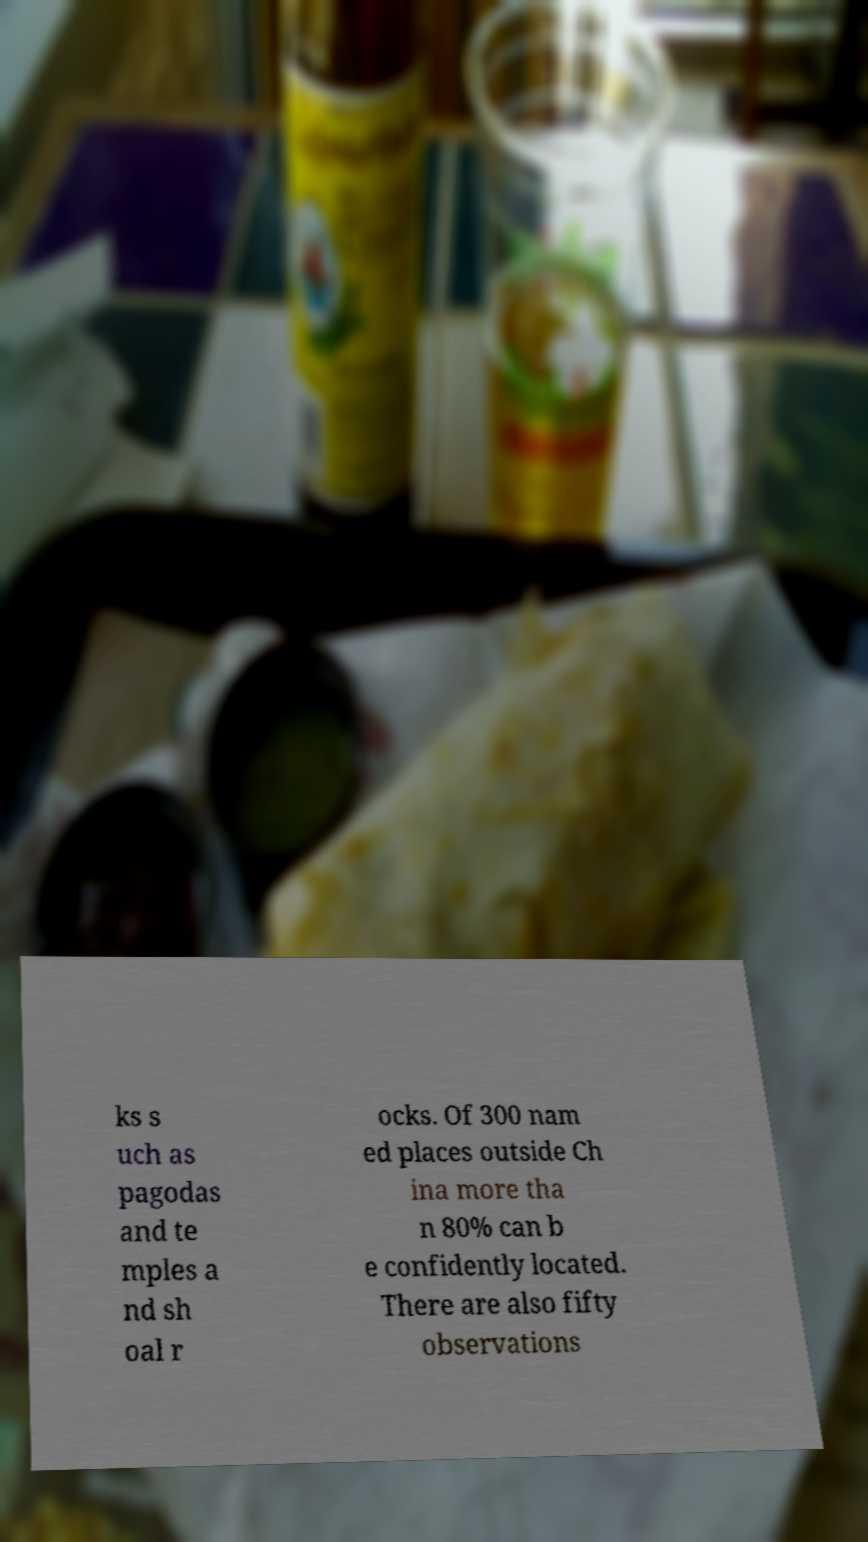I need the written content from this picture converted into text. Can you do that? ks s uch as pagodas and te mples a nd sh oal r ocks. Of 300 nam ed places outside Ch ina more tha n 80% can b e confidently located. There are also fifty observations 